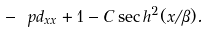Convert formula to latex. <formula><loc_0><loc_0><loc_500><loc_500>- \ p d _ { x x } + 1 - C \sec h ^ { 2 } ( x / \beta ) .</formula> 